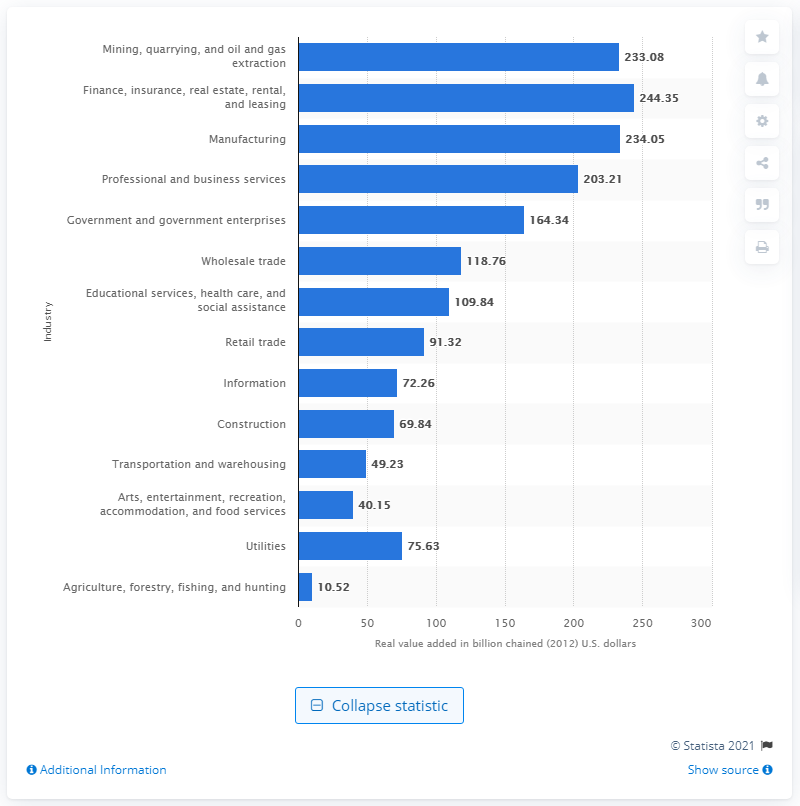Identify some key points in this picture. In 2012, the mining industry contributed a total of $233.08 to the Gross Domestic Product (GDP) of Texas. 